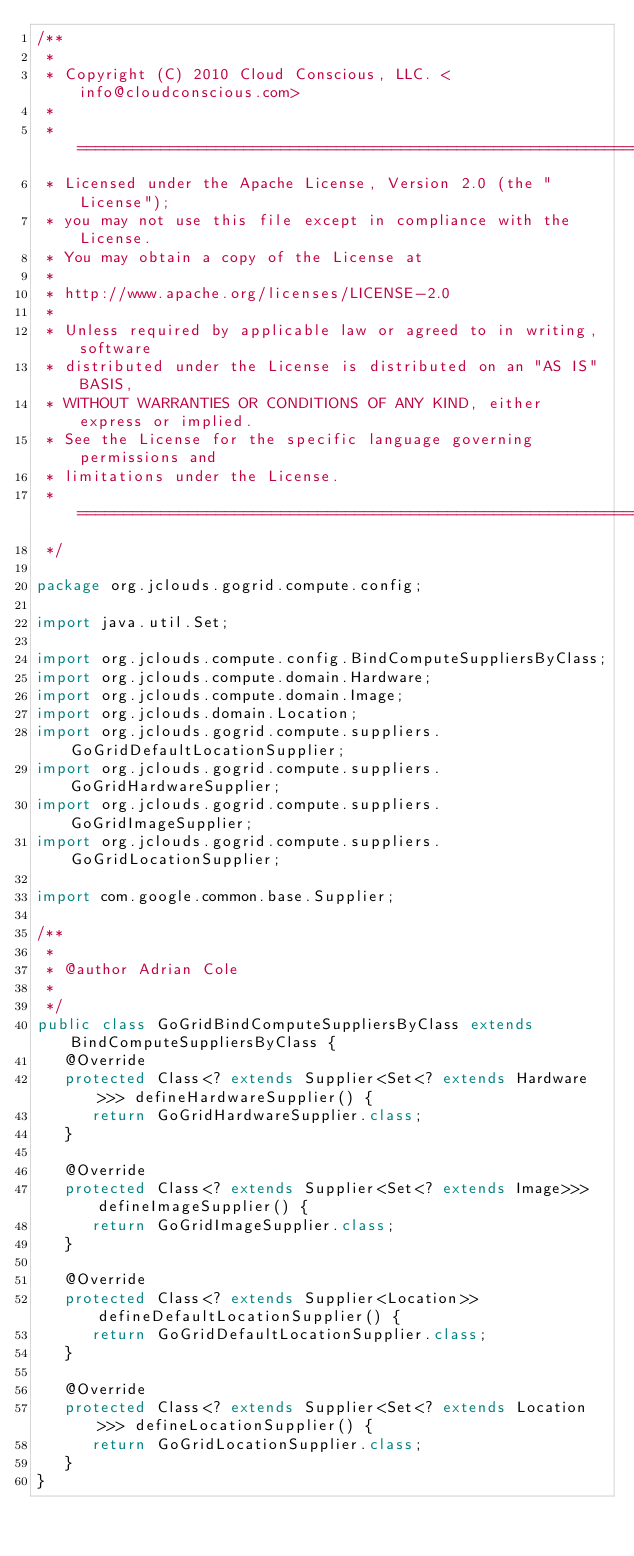Convert code to text. <code><loc_0><loc_0><loc_500><loc_500><_Java_>/**
 *
 * Copyright (C) 2010 Cloud Conscious, LLC. <info@cloudconscious.com>
 *
 * ====================================================================
 * Licensed under the Apache License, Version 2.0 (the "License");
 * you may not use this file except in compliance with the License.
 * You may obtain a copy of the License at
 *
 * http://www.apache.org/licenses/LICENSE-2.0
 *
 * Unless required by applicable law or agreed to in writing, software
 * distributed under the License is distributed on an "AS IS" BASIS,
 * WITHOUT WARRANTIES OR CONDITIONS OF ANY KIND, either express or implied.
 * See the License for the specific language governing permissions and
 * limitations under the License.
 * ====================================================================
 */

package org.jclouds.gogrid.compute.config;

import java.util.Set;

import org.jclouds.compute.config.BindComputeSuppliersByClass;
import org.jclouds.compute.domain.Hardware;
import org.jclouds.compute.domain.Image;
import org.jclouds.domain.Location;
import org.jclouds.gogrid.compute.suppliers.GoGridDefaultLocationSupplier;
import org.jclouds.gogrid.compute.suppliers.GoGridHardwareSupplier;
import org.jclouds.gogrid.compute.suppliers.GoGridImageSupplier;
import org.jclouds.gogrid.compute.suppliers.GoGridLocationSupplier;

import com.google.common.base.Supplier;

/**
 * 
 * @author Adrian Cole
 * 
 */
public class GoGridBindComputeSuppliersByClass extends BindComputeSuppliersByClass {
   @Override
   protected Class<? extends Supplier<Set<? extends Hardware>>> defineHardwareSupplier() {
      return GoGridHardwareSupplier.class;
   }

   @Override
   protected Class<? extends Supplier<Set<? extends Image>>> defineImageSupplier() {
      return GoGridImageSupplier.class;
   }

   @Override
   protected Class<? extends Supplier<Location>> defineDefaultLocationSupplier() {
      return GoGridDefaultLocationSupplier.class;
   }

   @Override
   protected Class<? extends Supplier<Set<? extends Location>>> defineLocationSupplier() {
      return GoGridLocationSupplier.class;
   }
}</code> 